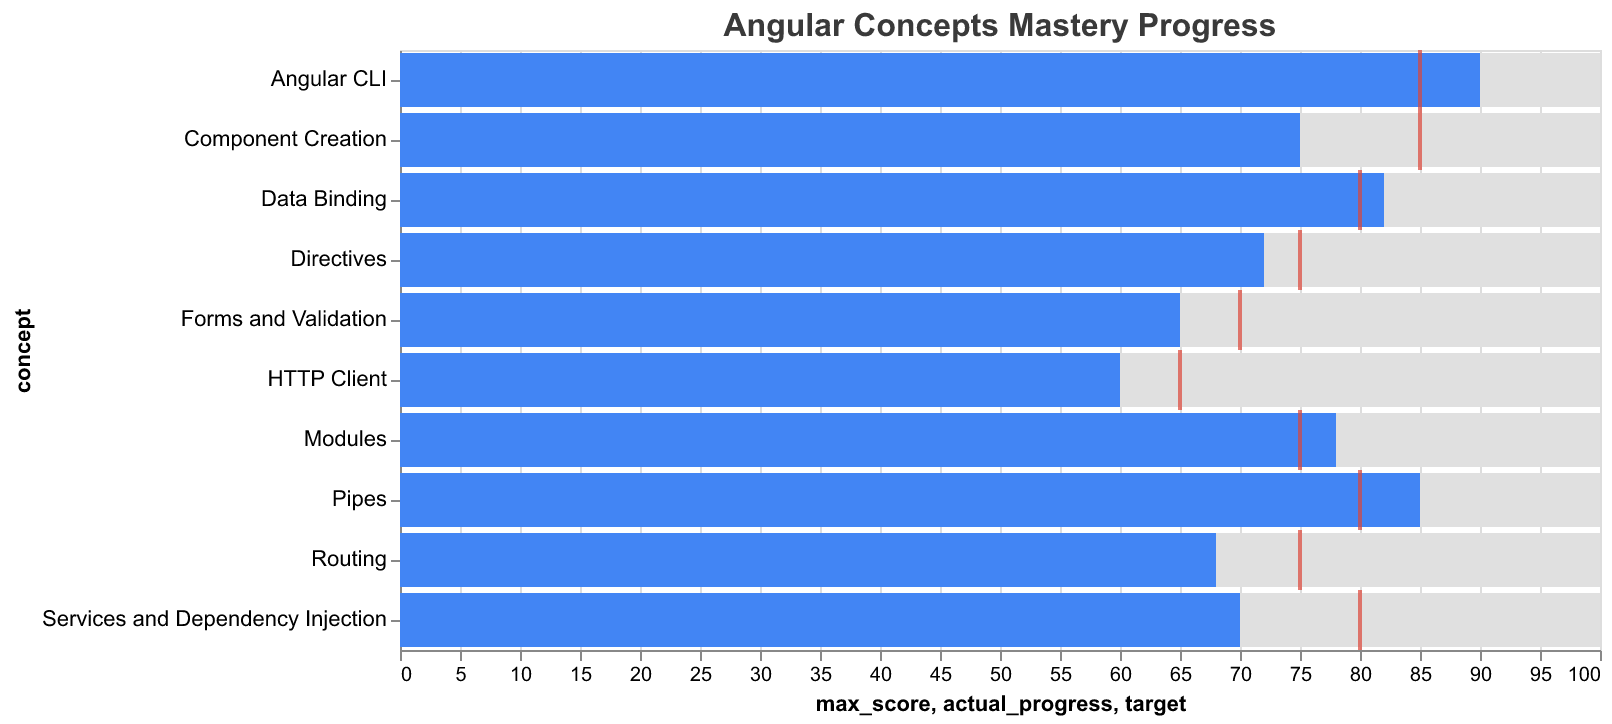What is the title of the chart? The title of the chart is displayed prominently at the top. It helps understand the subject at a glance.
Answer: Angular Concepts Mastery Progress Which Angular concept has the highest actual progress? To find the highest actual progress, look for the bar that extends the farthest to the right.
Answer: Angular CLI What is the actual progress for the concept 'Routing'? Locate the bar labeled 'Routing' and read the corresponding value at its end.
Answer: 68 Which concept exceeded its target the most? Calculate the difference between the actual progress and target for each concept. The concept with the highest positive difference is the answer.
Answer: Pipes What is the average actual progress of all concepts? Sum all the actual progress values and divide by the number of concepts. The sum is 745, and the number of concepts is 10.
Answer: 74.5 How many concepts have an actual progress greater than 80? Count the number of concepts with their actual progress bars extending beyond the 80 mark on the x-axis.
Answer: 4 What is the difference between the target and actual progress for 'Services and Dependency Injection'? Subtract the actual progress from the target for this concept. The target is 80, and the actual progress is 70.
Answer: 10 Which concept has an actual progress closest to its target? Calculate the absolute difference between actual progress and target for all concepts. The smallest difference indicates the concept that is closest to its target.
Answer: Data Binding For which concept is the target the highest? Check the red ticks which represent the targets and find the one that is farthest to the right on the x-axis.
Answer: Component Creation, Services and Dependency Injection Which concept has the lowest actual progress? Look for the bar that is the shortest, indicating the lowest actual progress value.
Answer: HTTP Client 